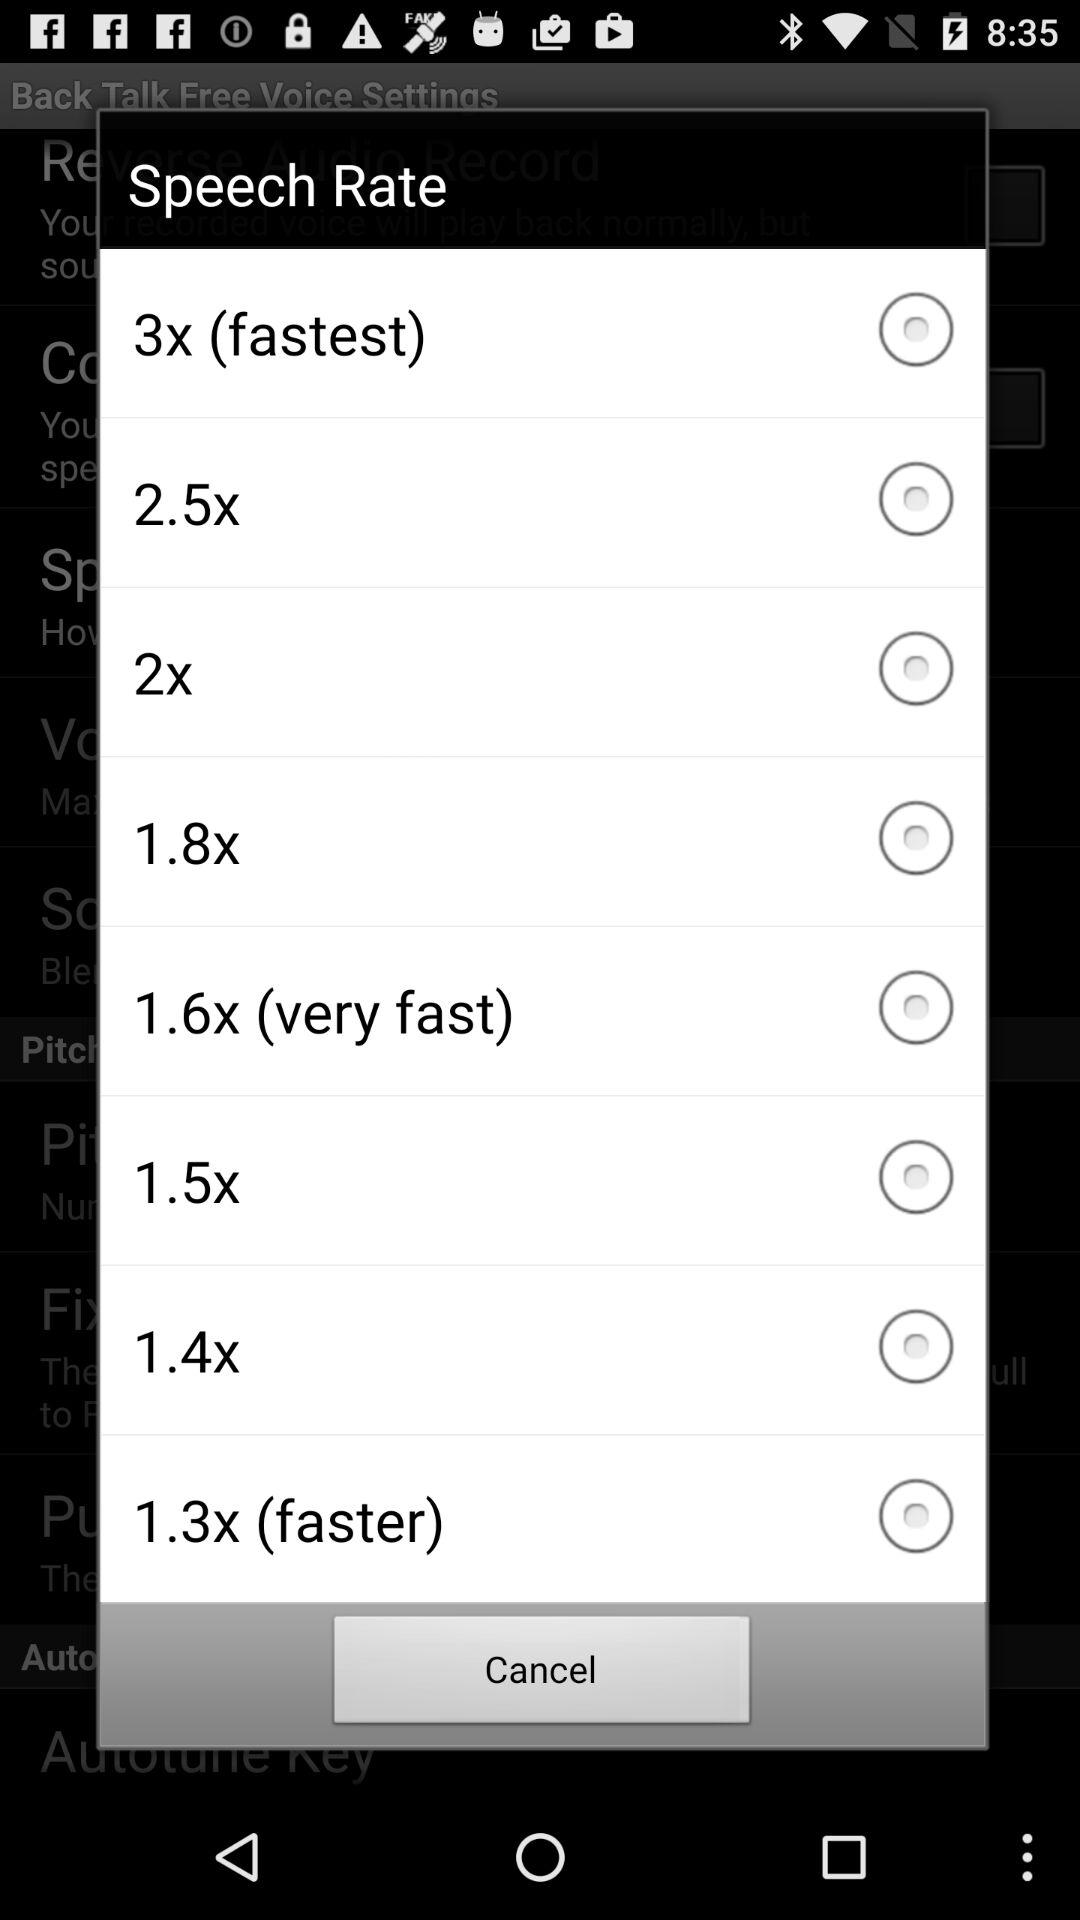How many speech rate options are faster than 1.5x?
Answer the question using a single word or phrase. 5 